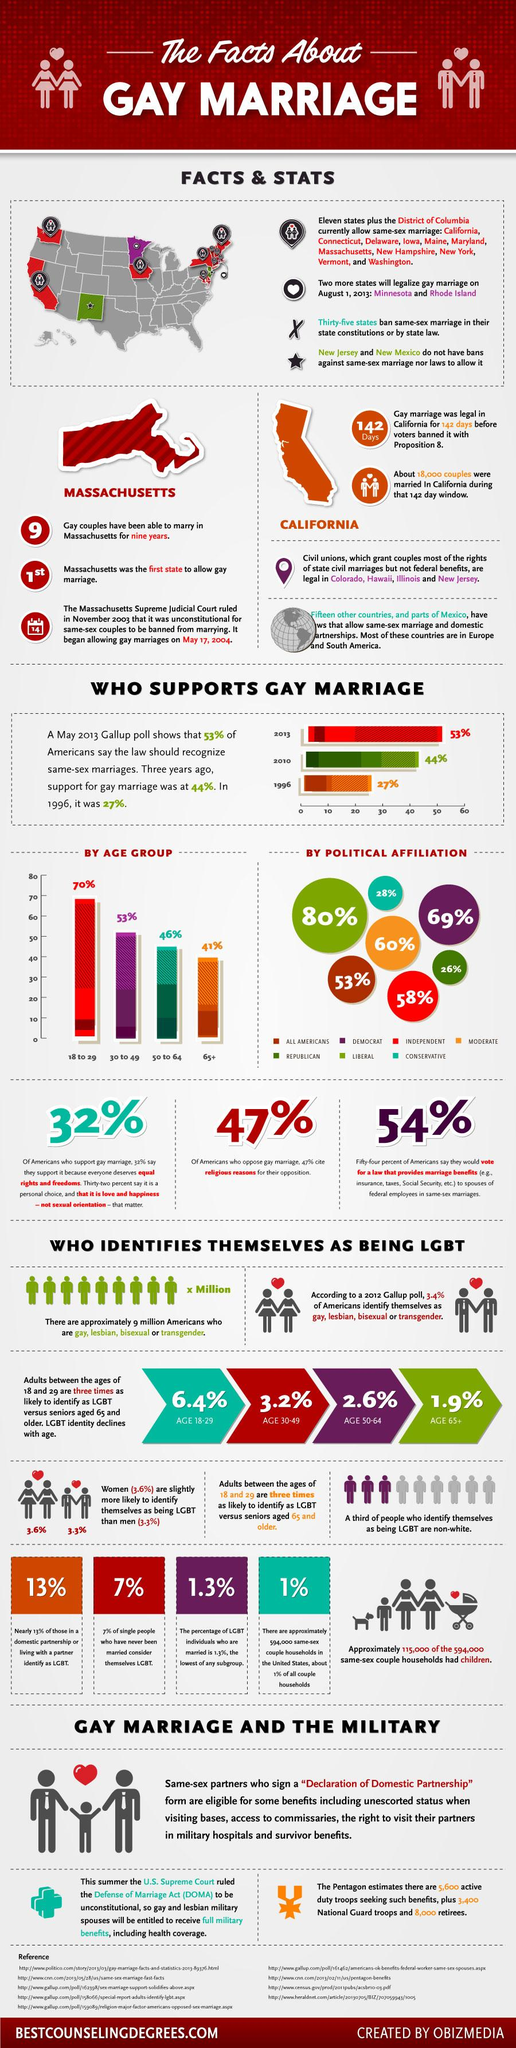Identify some key points in this picture. Nine references are cited in this text. In the years from 1996 to 2013, there was a significant increase in support for gay marriage, with a growth rate of 26%. A recent survey revealed that 28% of conservatives support same-sex marriage. The support for gay marriage differs by 43% among Democrats and Republicans. A recent survey has revealed that 41% of senior citizens support gay marriage. 